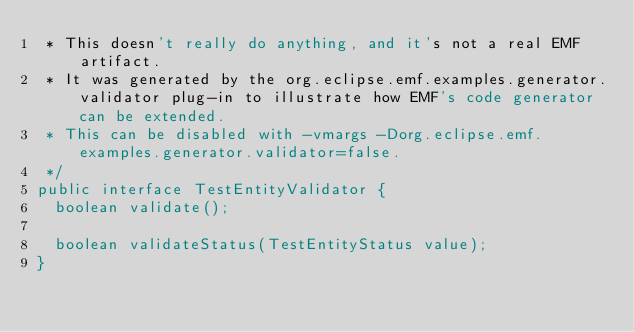Convert code to text. <code><loc_0><loc_0><loc_500><loc_500><_Java_> * This doesn't really do anything, and it's not a real EMF artifact.
 * It was generated by the org.eclipse.emf.examples.generator.validator plug-in to illustrate how EMF's code generator can be extended.
 * This can be disabled with -vmargs -Dorg.eclipse.emf.examples.generator.validator=false.
 */
public interface TestEntityValidator {
	boolean validate();

	boolean validateStatus(TestEntityStatus value);
}
</code> 